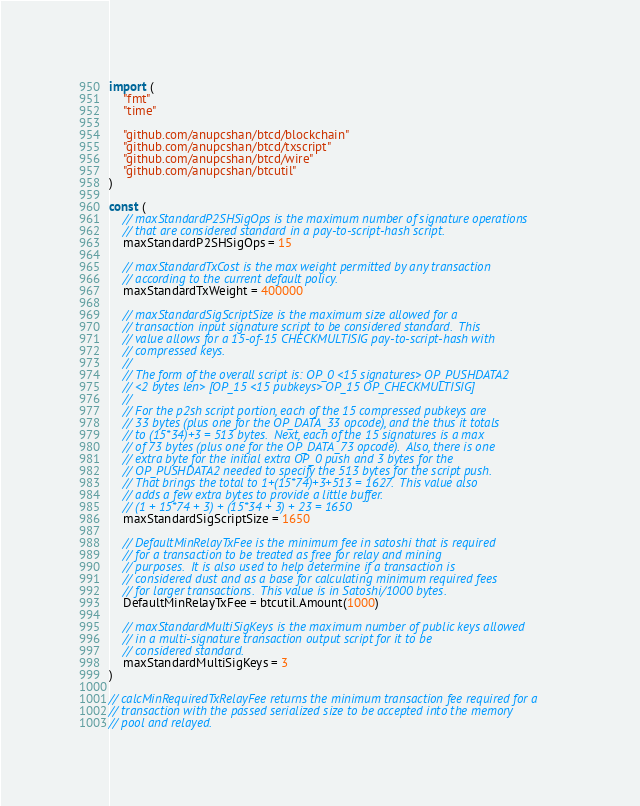Convert code to text. <code><loc_0><loc_0><loc_500><loc_500><_Go_>
import (
	"fmt"
	"time"

	"github.com/anupcshan/btcd/blockchain"
	"github.com/anupcshan/btcd/txscript"
	"github.com/anupcshan/btcd/wire"
	"github.com/anupcshan/btcutil"
)

const (
	// maxStandardP2SHSigOps is the maximum number of signature operations
	// that are considered standard in a pay-to-script-hash script.
	maxStandardP2SHSigOps = 15

	// maxStandardTxCost is the max weight permitted by any transaction
	// according to the current default policy.
	maxStandardTxWeight = 400000

	// maxStandardSigScriptSize is the maximum size allowed for a
	// transaction input signature script to be considered standard.  This
	// value allows for a 15-of-15 CHECKMULTISIG pay-to-script-hash with
	// compressed keys.
	//
	// The form of the overall script is: OP_0 <15 signatures> OP_PUSHDATA2
	// <2 bytes len> [OP_15 <15 pubkeys> OP_15 OP_CHECKMULTISIG]
	//
	// For the p2sh script portion, each of the 15 compressed pubkeys are
	// 33 bytes (plus one for the OP_DATA_33 opcode), and the thus it totals
	// to (15*34)+3 = 513 bytes.  Next, each of the 15 signatures is a max
	// of 73 bytes (plus one for the OP_DATA_73 opcode).  Also, there is one
	// extra byte for the initial extra OP_0 push and 3 bytes for the
	// OP_PUSHDATA2 needed to specify the 513 bytes for the script push.
	// That brings the total to 1+(15*74)+3+513 = 1627.  This value also
	// adds a few extra bytes to provide a little buffer.
	// (1 + 15*74 + 3) + (15*34 + 3) + 23 = 1650
	maxStandardSigScriptSize = 1650

	// DefaultMinRelayTxFee is the minimum fee in satoshi that is required
	// for a transaction to be treated as free for relay and mining
	// purposes.  It is also used to help determine if a transaction is
	// considered dust and as a base for calculating minimum required fees
	// for larger transactions.  This value is in Satoshi/1000 bytes.
	DefaultMinRelayTxFee = btcutil.Amount(1000)

	// maxStandardMultiSigKeys is the maximum number of public keys allowed
	// in a multi-signature transaction output script for it to be
	// considered standard.
	maxStandardMultiSigKeys = 3
)

// calcMinRequiredTxRelayFee returns the minimum transaction fee required for a
// transaction with the passed serialized size to be accepted into the memory
// pool and relayed.</code> 